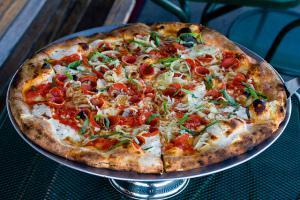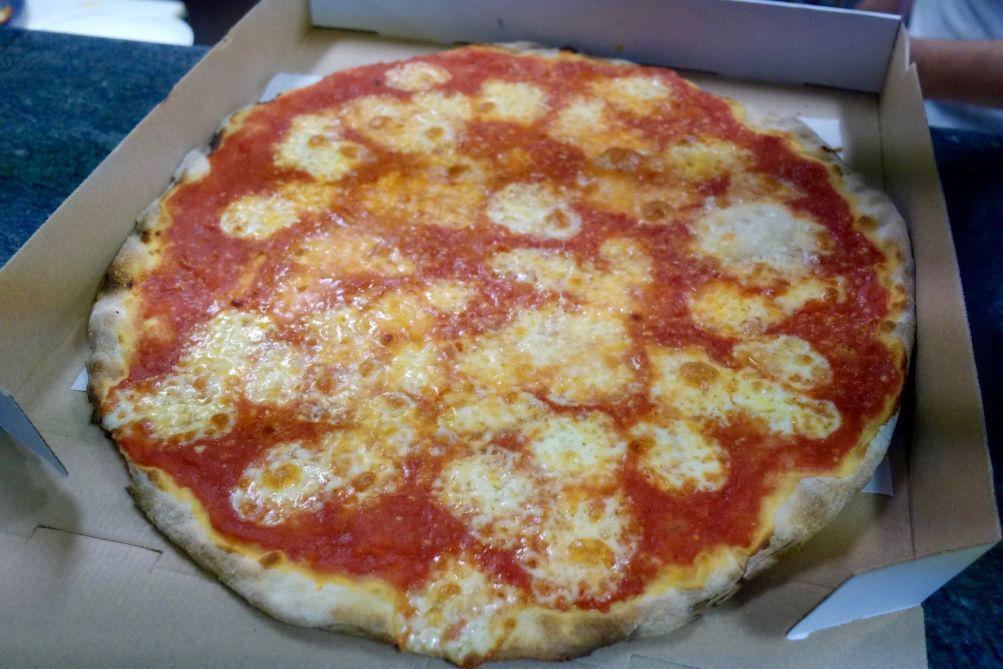The first image is the image on the left, the second image is the image on the right. Examine the images to the left and right. Is the description "A pizza in one image is intact, while a second image shows a slice of pizza and a paper plate." accurate? Answer yes or no. No. The first image is the image on the left, the second image is the image on the right. Evaluate the accuracy of this statement regarding the images: "The right image shows a whole pizza on a silver tray, and the left image shows one pizza slice on a white paper plate next to a silver tray containing less than a whole pizza.". Is it true? Answer yes or no. No. 